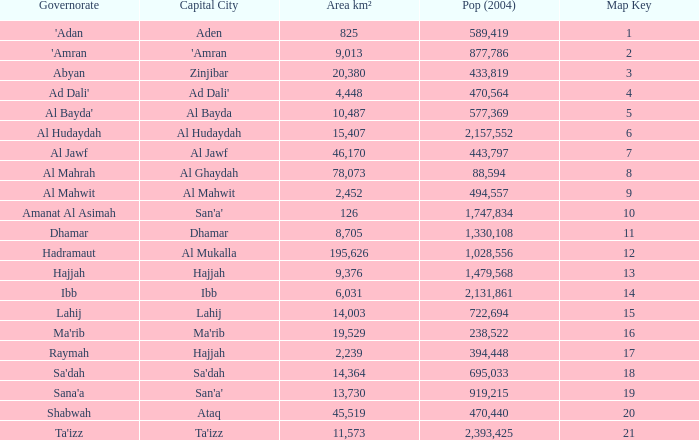How many Map Key has an Area km² larger than 14,003 and a Capital City of al mukalla, and a Pop (2004) larger than 1,028,556? None. 